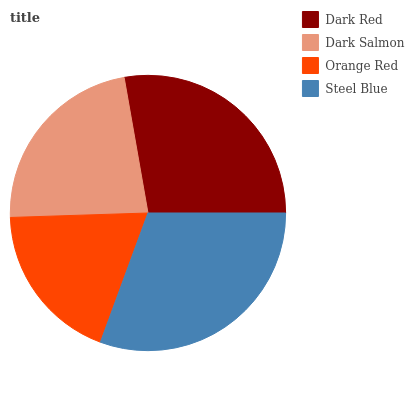Is Orange Red the minimum?
Answer yes or no. Yes. Is Steel Blue the maximum?
Answer yes or no. Yes. Is Dark Salmon the minimum?
Answer yes or no. No. Is Dark Salmon the maximum?
Answer yes or no. No. Is Dark Red greater than Dark Salmon?
Answer yes or no. Yes. Is Dark Salmon less than Dark Red?
Answer yes or no. Yes. Is Dark Salmon greater than Dark Red?
Answer yes or no. No. Is Dark Red less than Dark Salmon?
Answer yes or no. No. Is Dark Red the high median?
Answer yes or no. Yes. Is Dark Salmon the low median?
Answer yes or no. Yes. Is Orange Red the high median?
Answer yes or no. No. Is Orange Red the low median?
Answer yes or no. No. 